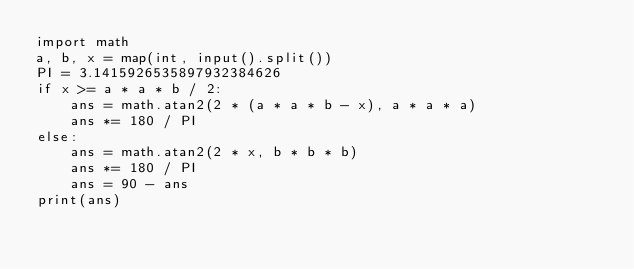Convert code to text. <code><loc_0><loc_0><loc_500><loc_500><_Python_>import math
a, b, x = map(int, input().split())
PI = 3.1415926535897932384626
if x >= a * a * b / 2:
    ans = math.atan2(2 * (a * a * b - x), a * a * a)
    ans *= 180 / PI
else:
    ans = math.atan2(2 * x, b * b * b)
    ans *= 180 / PI
    ans = 90 - ans
print(ans)</code> 